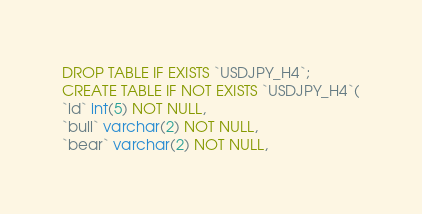Convert code to text. <code><loc_0><loc_0><loc_500><loc_500><_SQL_>DROP TABLE IF EXISTS `USDJPY_H4`;
CREATE TABLE IF NOT EXISTS `USDJPY_H4`(
`id` int(5) NOT NULL,
`bull` varchar(2) NOT NULL,
`bear` varchar(2) NOT NULL,</code> 